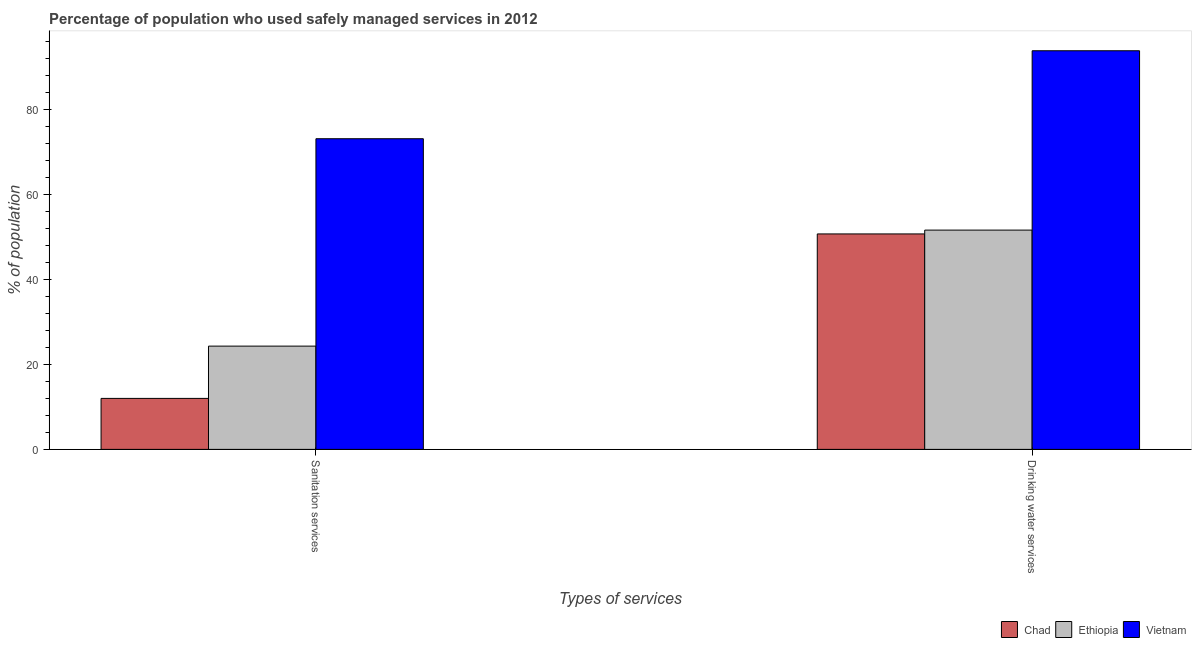How many different coloured bars are there?
Give a very brief answer. 3. How many groups of bars are there?
Your response must be concise. 2. Are the number of bars per tick equal to the number of legend labels?
Keep it short and to the point. Yes. How many bars are there on the 2nd tick from the right?
Give a very brief answer. 3. What is the label of the 2nd group of bars from the left?
Your answer should be compact. Drinking water services. What is the percentage of population who used sanitation services in Vietnam?
Your answer should be very brief. 73.1. Across all countries, what is the maximum percentage of population who used sanitation services?
Your response must be concise. 73.1. Across all countries, what is the minimum percentage of population who used drinking water services?
Offer a terse response. 50.7. In which country was the percentage of population who used drinking water services maximum?
Ensure brevity in your answer.  Vietnam. In which country was the percentage of population who used drinking water services minimum?
Your response must be concise. Chad. What is the total percentage of population who used sanitation services in the graph?
Provide a succinct answer. 109.4. What is the difference between the percentage of population who used drinking water services in Vietnam and that in Chad?
Give a very brief answer. 43.1. What is the difference between the percentage of population who used drinking water services in Chad and the percentage of population who used sanitation services in Ethiopia?
Your answer should be compact. 26.4. What is the average percentage of population who used sanitation services per country?
Offer a terse response. 36.47. What is the difference between the percentage of population who used sanitation services and percentage of population who used drinking water services in Chad?
Provide a short and direct response. -38.7. In how many countries, is the percentage of population who used drinking water services greater than 84 %?
Provide a short and direct response. 1. What is the ratio of the percentage of population who used drinking water services in Ethiopia to that in Vietnam?
Provide a succinct answer. 0.55. In how many countries, is the percentage of population who used sanitation services greater than the average percentage of population who used sanitation services taken over all countries?
Offer a terse response. 1. What does the 2nd bar from the left in Drinking water services represents?
Give a very brief answer. Ethiopia. What does the 3rd bar from the right in Drinking water services represents?
Keep it short and to the point. Chad. How many bars are there?
Provide a short and direct response. 6. How many countries are there in the graph?
Ensure brevity in your answer.  3. Does the graph contain any zero values?
Ensure brevity in your answer.  No. Where does the legend appear in the graph?
Give a very brief answer. Bottom right. How are the legend labels stacked?
Your response must be concise. Horizontal. What is the title of the graph?
Ensure brevity in your answer.  Percentage of population who used safely managed services in 2012. What is the label or title of the X-axis?
Offer a terse response. Types of services. What is the label or title of the Y-axis?
Your answer should be very brief. % of population. What is the % of population of Chad in Sanitation services?
Provide a succinct answer. 12. What is the % of population of Ethiopia in Sanitation services?
Ensure brevity in your answer.  24.3. What is the % of population of Vietnam in Sanitation services?
Give a very brief answer. 73.1. What is the % of population in Chad in Drinking water services?
Your answer should be very brief. 50.7. What is the % of population in Ethiopia in Drinking water services?
Your answer should be compact. 51.6. What is the % of population in Vietnam in Drinking water services?
Provide a succinct answer. 93.8. Across all Types of services, what is the maximum % of population of Chad?
Ensure brevity in your answer.  50.7. Across all Types of services, what is the maximum % of population in Ethiopia?
Provide a short and direct response. 51.6. Across all Types of services, what is the maximum % of population of Vietnam?
Keep it short and to the point. 93.8. Across all Types of services, what is the minimum % of population in Chad?
Ensure brevity in your answer.  12. Across all Types of services, what is the minimum % of population in Ethiopia?
Make the answer very short. 24.3. Across all Types of services, what is the minimum % of population of Vietnam?
Ensure brevity in your answer.  73.1. What is the total % of population in Chad in the graph?
Provide a short and direct response. 62.7. What is the total % of population of Ethiopia in the graph?
Ensure brevity in your answer.  75.9. What is the total % of population of Vietnam in the graph?
Your answer should be very brief. 166.9. What is the difference between the % of population in Chad in Sanitation services and that in Drinking water services?
Offer a terse response. -38.7. What is the difference between the % of population of Ethiopia in Sanitation services and that in Drinking water services?
Make the answer very short. -27.3. What is the difference between the % of population in Vietnam in Sanitation services and that in Drinking water services?
Offer a very short reply. -20.7. What is the difference between the % of population in Chad in Sanitation services and the % of population in Ethiopia in Drinking water services?
Keep it short and to the point. -39.6. What is the difference between the % of population of Chad in Sanitation services and the % of population of Vietnam in Drinking water services?
Make the answer very short. -81.8. What is the difference between the % of population of Ethiopia in Sanitation services and the % of population of Vietnam in Drinking water services?
Offer a very short reply. -69.5. What is the average % of population of Chad per Types of services?
Your answer should be compact. 31.35. What is the average % of population of Ethiopia per Types of services?
Make the answer very short. 37.95. What is the average % of population in Vietnam per Types of services?
Your response must be concise. 83.45. What is the difference between the % of population in Chad and % of population in Ethiopia in Sanitation services?
Your answer should be very brief. -12.3. What is the difference between the % of population of Chad and % of population of Vietnam in Sanitation services?
Give a very brief answer. -61.1. What is the difference between the % of population of Ethiopia and % of population of Vietnam in Sanitation services?
Make the answer very short. -48.8. What is the difference between the % of population in Chad and % of population in Vietnam in Drinking water services?
Keep it short and to the point. -43.1. What is the difference between the % of population in Ethiopia and % of population in Vietnam in Drinking water services?
Provide a short and direct response. -42.2. What is the ratio of the % of population of Chad in Sanitation services to that in Drinking water services?
Provide a succinct answer. 0.24. What is the ratio of the % of population in Ethiopia in Sanitation services to that in Drinking water services?
Your answer should be compact. 0.47. What is the ratio of the % of population in Vietnam in Sanitation services to that in Drinking water services?
Ensure brevity in your answer.  0.78. What is the difference between the highest and the second highest % of population of Chad?
Offer a terse response. 38.7. What is the difference between the highest and the second highest % of population of Ethiopia?
Give a very brief answer. 27.3. What is the difference between the highest and the second highest % of population of Vietnam?
Offer a very short reply. 20.7. What is the difference between the highest and the lowest % of population of Chad?
Ensure brevity in your answer.  38.7. What is the difference between the highest and the lowest % of population in Ethiopia?
Your answer should be very brief. 27.3. What is the difference between the highest and the lowest % of population in Vietnam?
Your answer should be compact. 20.7. 